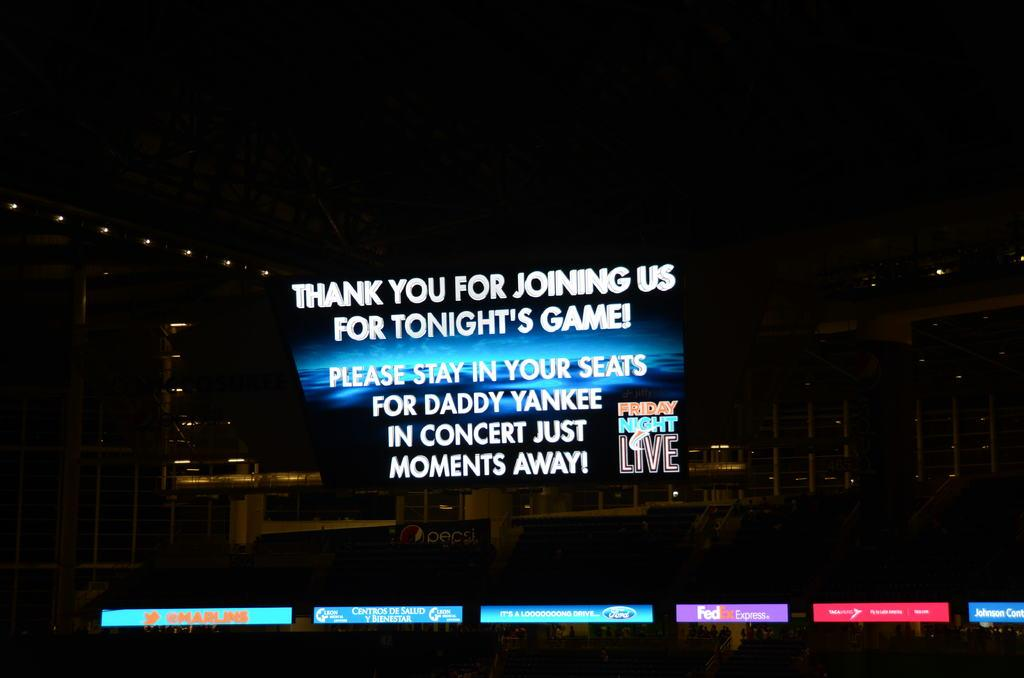<image>
Describe the image concisely. a billboard that says 'thank you for joining us for tonight's game!' 